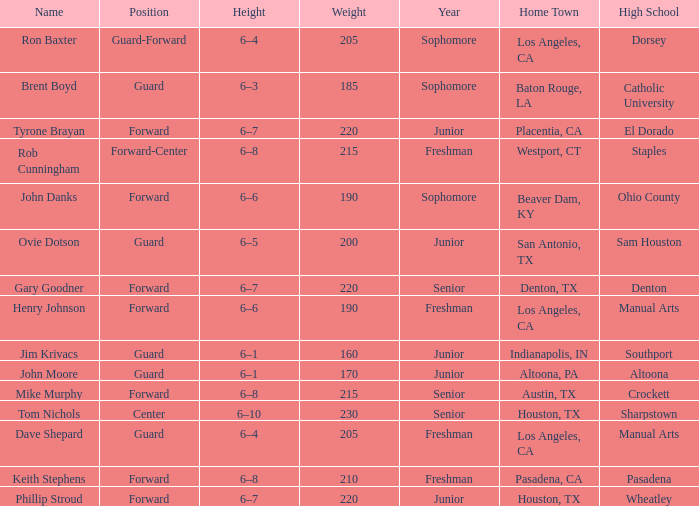What is the name along with a year of a junior, and a high school connected to wheatley? Phillip Stroud. Could you help me parse every detail presented in this table? {'header': ['Name', 'Position', 'Height', 'Weight', 'Year', 'Home Town', 'High School'], 'rows': [['Ron Baxter', 'Guard-Forward', '6–4', '205', 'Sophomore', 'Los Angeles, CA', 'Dorsey'], ['Brent Boyd', 'Guard', '6–3', '185', 'Sophomore', 'Baton Rouge, LA', 'Catholic University'], ['Tyrone Brayan', 'Forward', '6–7', '220', 'Junior', 'Placentia, CA', 'El Dorado'], ['Rob Cunningham', 'Forward-Center', '6–8', '215', 'Freshman', 'Westport, CT', 'Staples'], ['John Danks', 'Forward', '6–6', '190', 'Sophomore', 'Beaver Dam, KY', 'Ohio County'], ['Ovie Dotson', 'Guard', '6–5', '200', 'Junior', 'San Antonio, TX', 'Sam Houston'], ['Gary Goodner', 'Forward', '6–7', '220', 'Senior', 'Denton, TX', 'Denton'], ['Henry Johnson', 'Forward', '6–6', '190', 'Freshman', 'Los Angeles, CA', 'Manual Arts'], ['Jim Krivacs', 'Guard', '6–1', '160', 'Junior', 'Indianapolis, IN', 'Southport'], ['John Moore', 'Guard', '6–1', '170', 'Junior', 'Altoona, PA', 'Altoona'], ['Mike Murphy', 'Forward', '6–8', '215', 'Senior', 'Austin, TX', 'Crockett'], ['Tom Nichols', 'Center', '6–10', '230', 'Senior', 'Houston, TX', 'Sharpstown'], ['Dave Shepard', 'Guard', '6–4', '205', 'Freshman', 'Los Angeles, CA', 'Manual Arts'], ['Keith Stephens', 'Forward', '6–8', '210', 'Freshman', 'Pasadena, CA', 'Pasadena'], ['Phillip Stroud', 'Forward', '6–7', '220', 'Junior', 'Houston, TX', 'Wheatley']]} 